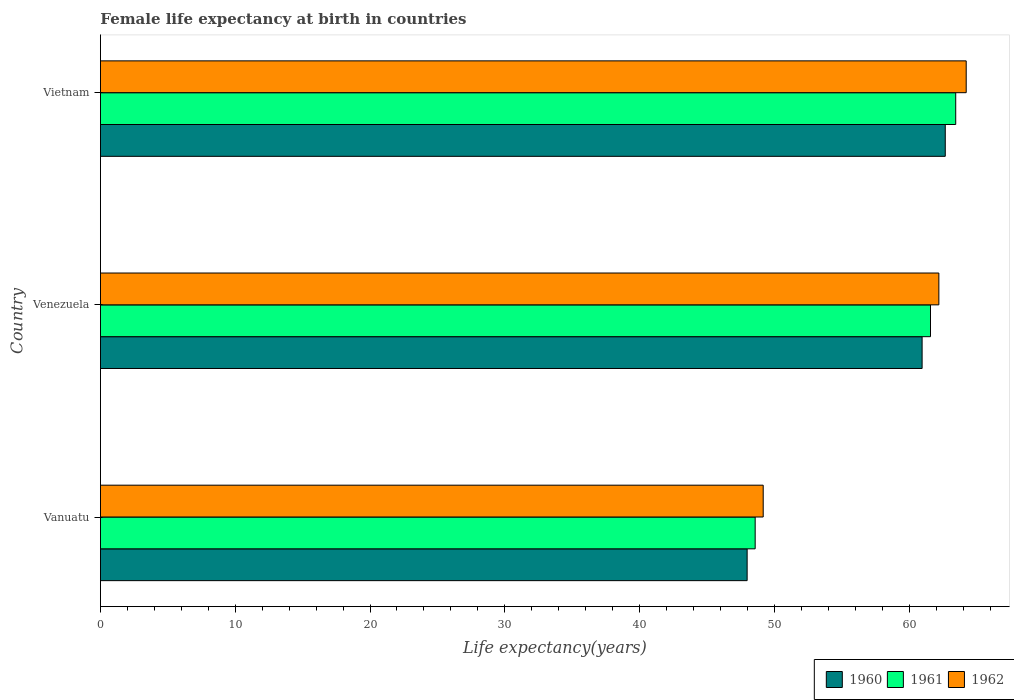How many different coloured bars are there?
Offer a terse response. 3. Are the number of bars on each tick of the Y-axis equal?
Give a very brief answer. Yes. How many bars are there on the 3rd tick from the bottom?
Ensure brevity in your answer.  3. What is the label of the 1st group of bars from the top?
Provide a succinct answer. Vietnam. In how many cases, is the number of bars for a given country not equal to the number of legend labels?
Your response must be concise. 0. What is the female life expectancy at birth in 1960 in Vietnam?
Give a very brief answer. 62.68. Across all countries, what is the maximum female life expectancy at birth in 1960?
Give a very brief answer. 62.68. Across all countries, what is the minimum female life expectancy at birth in 1960?
Give a very brief answer. 47.98. In which country was the female life expectancy at birth in 1960 maximum?
Keep it short and to the point. Vietnam. In which country was the female life expectancy at birth in 1960 minimum?
Provide a short and direct response. Vanuatu. What is the total female life expectancy at birth in 1960 in the graph?
Your answer should be compact. 171.62. What is the difference between the female life expectancy at birth in 1960 in Venezuela and that in Vietnam?
Ensure brevity in your answer.  -1.72. What is the difference between the female life expectancy at birth in 1962 in Venezuela and the female life expectancy at birth in 1960 in Vanuatu?
Offer a very short reply. 14.22. What is the average female life expectancy at birth in 1962 per country?
Keep it short and to the point. 58.53. What is the difference between the female life expectancy at birth in 1962 and female life expectancy at birth in 1961 in Vanuatu?
Give a very brief answer. 0.6. What is the ratio of the female life expectancy at birth in 1961 in Venezuela to that in Vietnam?
Make the answer very short. 0.97. Is the difference between the female life expectancy at birth in 1962 in Vanuatu and Vietnam greater than the difference between the female life expectancy at birth in 1961 in Vanuatu and Vietnam?
Ensure brevity in your answer.  No. What is the difference between the highest and the second highest female life expectancy at birth in 1962?
Offer a terse response. 2.03. What is the difference between the highest and the lowest female life expectancy at birth in 1961?
Your response must be concise. 14.88. Is the sum of the female life expectancy at birth in 1960 in Venezuela and Vietnam greater than the maximum female life expectancy at birth in 1962 across all countries?
Provide a short and direct response. Yes. How many bars are there?
Your response must be concise. 9. Where does the legend appear in the graph?
Your answer should be compact. Bottom right. How many legend labels are there?
Your response must be concise. 3. How are the legend labels stacked?
Provide a succinct answer. Horizontal. What is the title of the graph?
Offer a terse response. Female life expectancy at birth in countries. What is the label or title of the X-axis?
Provide a succinct answer. Life expectancy(years). What is the Life expectancy(years) in 1960 in Vanuatu?
Your answer should be very brief. 47.98. What is the Life expectancy(years) in 1961 in Vanuatu?
Offer a very short reply. 48.58. What is the Life expectancy(years) of 1962 in Vanuatu?
Give a very brief answer. 49.17. What is the Life expectancy(years) of 1960 in Venezuela?
Your answer should be very brief. 60.96. What is the Life expectancy(years) in 1961 in Venezuela?
Provide a short and direct response. 61.58. What is the Life expectancy(years) in 1962 in Venezuela?
Give a very brief answer. 62.2. What is the Life expectancy(years) in 1960 in Vietnam?
Your answer should be very brief. 62.68. What is the Life expectancy(years) of 1961 in Vietnam?
Make the answer very short. 63.45. What is the Life expectancy(years) in 1962 in Vietnam?
Your answer should be compact. 64.23. Across all countries, what is the maximum Life expectancy(years) of 1960?
Your response must be concise. 62.68. Across all countries, what is the maximum Life expectancy(years) of 1961?
Your answer should be compact. 63.45. Across all countries, what is the maximum Life expectancy(years) of 1962?
Your response must be concise. 64.23. Across all countries, what is the minimum Life expectancy(years) in 1960?
Give a very brief answer. 47.98. Across all countries, what is the minimum Life expectancy(years) of 1961?
Give a very brief answer. 48.58. Across all countries, what is the minimum Life expectancy(years) of 1962?
Offer a terse response. 49.17. What is the total Life expectancy(years) in 1960 in the graph?
Ensure brevity in your answer.  171.62. What is the total Life expectancy(years) of 1961 in the graph?
Offer a very short reply. 173.61. What is the total Life expectancy(years) in 1962 in the graph?
Offer a terse response. 175.6. What is the difference between the Life expectancy(years) in 1960 in Vanuatu and that in Venezuela?
Give a very brief answer. -12.98. What is the difference between the Life expectancy(years) in 1961 in Vanuatu and that in Venezuela?
Keep it short and to the point. -13.01. What is the difference between the Life expectancy(years) of 1962 in Vanuatu and that in Venezuela?
Make the answer very short. -13.03. What is the difference between the Life expectancy(years) in 1960 in Vanuatu and that in Vietnam?
Provide a short and direct response. -14.7. What is the difference between the Life expectancy(years) of 1961 in Vanuatu and that in Vietnam?
Provide a succinct answer. -14.88. What is the difference between the Life expectancy(years) of 1962 in Vanuatu and that in Vietnam?
Give a very brief answer. -15.06. What is the difference between the Life expectancy(years) in 1960 in Venezuela and that in Vietnam?
Make the answer very short. -1.72. What is the difference between the Life expectancy(years) of 1961 in Venezuela and that in Vietnam?
Your response must be concise. -1.87. What is the difference between the Life expectancy(years) of 1962 in Venezuela and that in Vietnam?
Your answer should be compact. -2.03. What is the difference between the Life expectancy(years) in 1960 in Vanuatu and the Life expectancy(years) in 1961 in Venezuela?
Make the answer very short. -13.6. What is the difference between the Life expectancy(years) in 1960 in Vanuatu and the Life expectancy(years) in 1962 in Venezuela?
Provide a succinct answer. -14.22. What is the difference between the Life expectancy(years) of 1961 in Vanuatu and the Life expectancy(years) of 1962 in Venezuela?
Provide a succinct answer. -13.63. What is the difference between the Life expectancy(years) of 1960 in Vanuatu and the Life expectancy(years) of 1961 in Vietnam?
Provide a succinct answer. -15.47. What is the difference between the Life expectancy(years) of 1960 in Vanuatu and the Life expectancy(years) of 1962 in Vietnam?
Keep it short and to the point. -16.25. What is the difference between the Life expectancy(years) of 1961 in Vanuatu and the Life expectancy(years) of 1962 in Vietnam?
Offer a terse response. -15.66. What is the difference between the Life expectancy(years) of 1960 in Venezuela and the Life expectancy(years) of 1961 in Vietnam?
Your answer should be compact. -2.49. What is the difference between the Life expectancy(years) of 1960 in Venezuela and the Life expectancy(years) of 1962 in Vietnam?
Provide a short and direct response. -3.27. What is the difference between the Life expectancy(years) of 1961 in Venezuela and the Life expectancy(years) of 1962 in Vietnam?
Your answer should be compact. -2.65. What is the average Life expectancy(years) of 1960 per country?
Your answer should be very brief. 57.21. What is the average Life expectancy(years) of 1961 per country?
Provide a succinct answer. 57.87. What is the average Life expectancy(years) of 1962 per country?
Your response must be concise. 58.53. What is the difference between the Life expectancy(years) of 1960 and Life expectancy(years) of 1961 in Vanuatu?
Keep it short and to the point. -0.6. What is the difference between the Life expectancy(years) of 1960 and Life expectancy(years) of 1962 in Vanuatu?
Offer a very short reply. -1.19. What is the difference between the Life expectancy(years) of 1961 and Life expectancy(years) of 1962 in Vanuatu?
Make the answer very short. -0.6. What is the difference between the Life expectancy(years) of 1960 and Life expectancy(years) of 1961 in Venezuela?
Offer a terse response. -0.62. What is the difference between the Life expectancy(years) of 1960 and Life expectancy(years) of 1962 in Venezuela?
Give a very brief answer. -1.24. What is the difference between the Life expectancy(years) of 1961 and Life expectancy(years) of 1962 in Venezuela?
Your answer should be very brief. -0.62. What is the difference between the Life expectancy(years) of 1960 and Life expectancy(years) of 1961 in Vietnam?
Your answer should be very brief. -0.78. What is the difference between the Life expectancy(years) in 1960 and Life expectancy(years) in 1962 in Vietnam?
Your answer should be very brief. -1.55. What is the difference between the Life expectancy(years) of 1961 and Life expectancy(years) of 1962 in Vietnam?
Provide a short and direct response. -0.78. What is the ratio of the Life expectancy(years) of 1960 in Vanuatu to that in Venezuela?
Make the answer very short. 0.79. What is the ratio of the Life expectancy(years) in 1961 in Vanuatu to that in Venezuela?
Your answer should be compact. 0.79. What is the ratio of the Life expectancy(years) in 1962 in Vanuatu to that in Venezuela?
Your response must be concise. 0.79. What is the ratio of the Life expectancy(years) in 1960 in Vanuatu to that in Vietnam?
Your response must be concise. 0.77. What is the ratio of the Life expectancy(years) in 1961 in Vanuatu to that in Vietnam?
Ensure brevity in your answer.  0.77. What is the ratio of the Life expectancy(years) in 1962 in Vanuatu to that in Vietnam?
Provide a succinct answer. 0.77. What is the ratio of the Life expectancy(years) of 1960 in Venezuela to that in Vietnam?
Give a very brief answer. 0.97. What is the ratio of the Life expectancy(years) of 1961 in Venezuela to that in Vietnam?
Give a very brief answer. 0.97. What is the ratio of the Life expectancy(years) in 1962 in Venezuela to that in Vietnam?
Provide a short and direct response. 0.97. What is the difference between the highest and the second highest Life expectancy(years) in 1960?
Offer a terse response. 1.72. What is the difference between the highest and the second highest Life expectancy(years) of 1961?
Keep it short and to the point. 1.87. What is the difference between the highest and the second highest Life expectancy(years) in 1962?
Offer a very short reply. 2.03. What is the difference between the highest and the lowest Life expectancy(years) of 1960?
Your answer should be compact. 14.7. What is the difference between the highest and the lowest Life expectancy(years) of 1961?
Provide a succinct answer. 14.88. What is the difference between the highest and the lowest Life expectancy(years) of 1962?
Give a very brief answer. 15.06. 